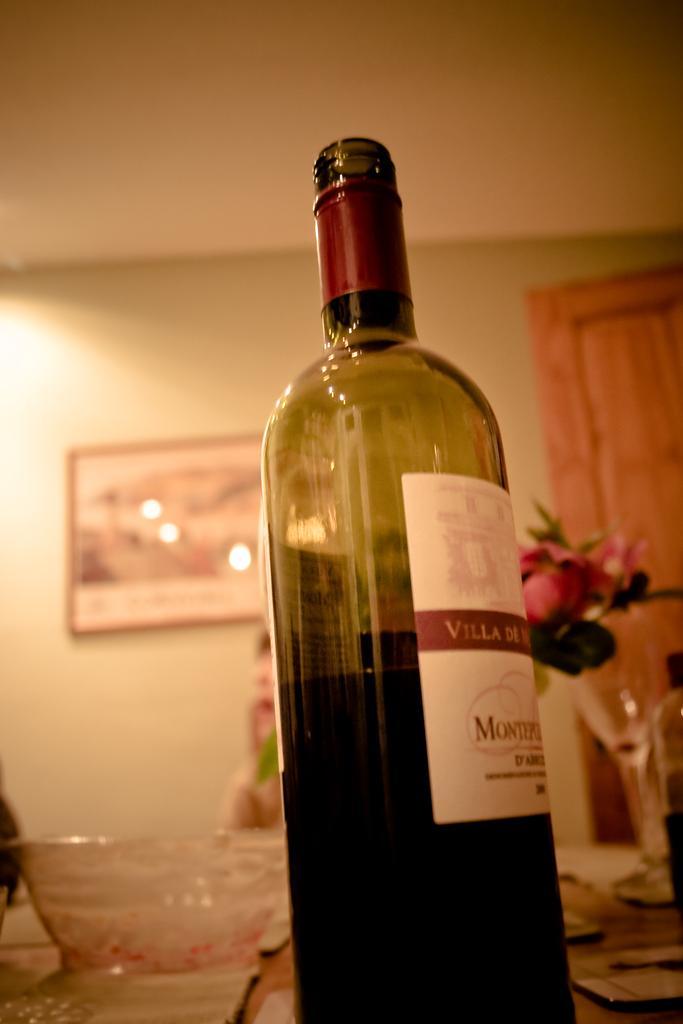How would you summarize this image in a sentence or two? In this image i can see a bottle,a cup. At the back ground i can see a flower pot, a person,the frame attached to a wall and a wooden door. 